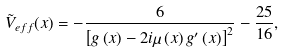Convert formula to latex. <formula><loc_0><loc_0><loc_500><loc_500>\tilde { V } _ { e f f } ( x ) = - \frac { 6 } { \left [ g \left ( x \right ) - 2 i \mu \left ( x \right ) g ^ { \prime } \left ( x \right ) \right ] ^ { 2 } } - \frac { 2 5 } { 1 6 } ,</formula> 